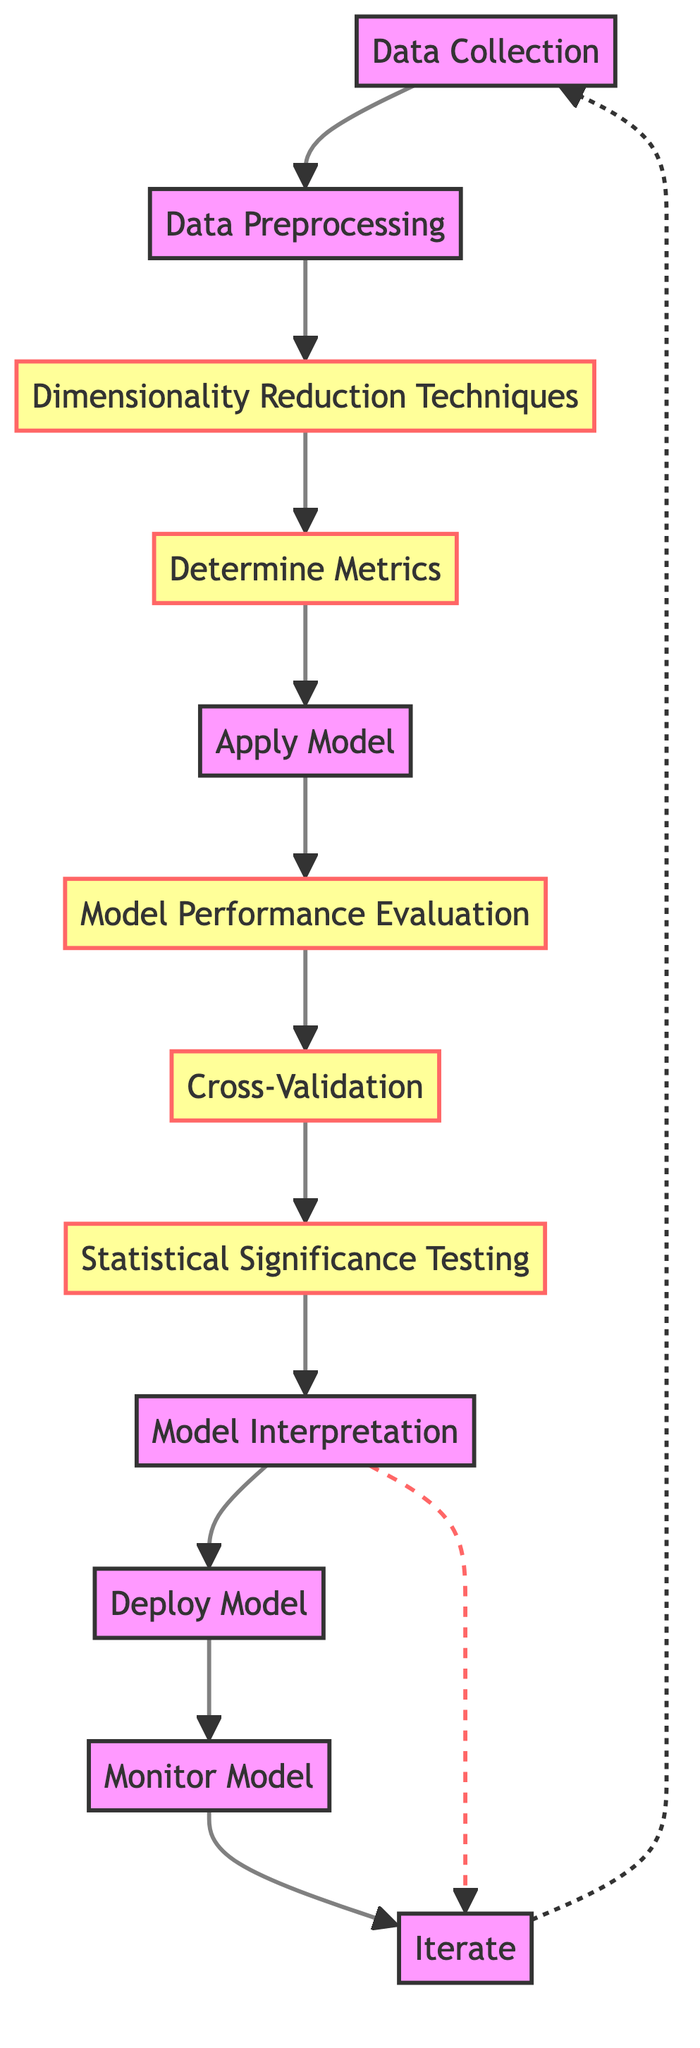What is the first step in the workflow? The first step in the workflow is indicated by the initial node, which is "Data Collection." This node directly connects to "Data Preprocessing," showing the sequence of actions taken.
Answer: Data Collection How many total nodes are present in the diagram? By counting each distinct process from the beginning to the end of the flowchart, we find there are a total of 12 nodes, including "Iterate," which connects back to "Data Collection."
Answer: 12 Which step follows "Model Performance Evaluation"? The diagram shows that "Model Performance Evaluation" leads to "Cross-Validation," as indicated by the direct arrow pointing to the next node in the flowchart.
Answer: Cross-Validation What is the key purpose of "Statistical Significance Testing"? The description provided in the diagram specifies that "Statistical Significance Testing" aims to "conduct tests like t-test, ANOVA to ensure results are statistically significant." This makes clear its role in validating the findings.
Answer: Ensure results are statistically significant Which processes are categorized as cautionary? In reviewing the diagram, the following processes are marked with the cautionary class: "Dimensionality Reduction Techniques," "Determine Metrics," "Model Performance Evaluation," "Cross-Validation," and "Statistical Significance Testing," highlighting areas of potential risk.
Answer: Dimensionality Reduction Techniques, Determine Metrics, Model Performance Evaluation, Cross-Validation, Statistical Significance Testing After "Model Interpretation," what are the two possible next steps? The flowchart indicates two paths from "Model Interpretation," leading to "Deploy Model" and "Iterate." This dual pathway demonstrates options for dealing with the results of the interpretation process.
Answer: Deploy Model, Iterate What is the final step in the workflow? The last node in the diagram is "Iterate," which connects back to "Data Collection," indicating that the workflow is designed to be cyclical in nature.
Answer: Iterate How does "Monitor Model" relate to the rest of the workflow? "Monitor Model" follows "Deploy Model," and it emphasizes the continuous aspect of the workflow, assessing the model's ongoing performance after it has been deployed. This creates a feedback loop that encourages regular updates.
Answer: Continuous assessment of deployed models 